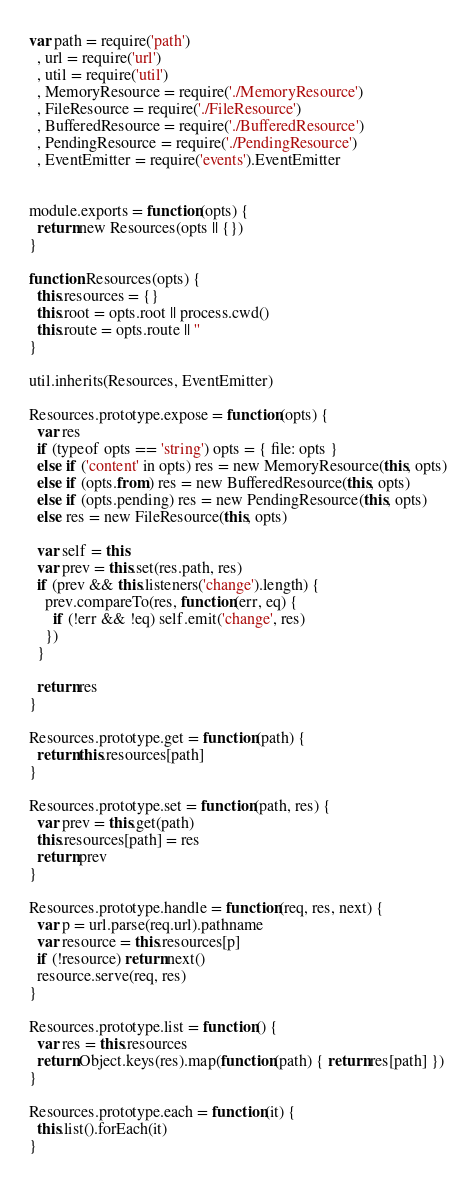<code> <loc_0><loc_0><loc_500><loc_500><_JavaScript_>var path = require('path')
  , url = require('url')
  , util = require('util')
  , MemoryResource = require('./MemoryResource')
  , FileResource = require('./FileResource')
  , BufferedResource = require('./BufferedResource')
  , PendingResource = require('./PendingResource')
  , EventEmitter = require('events').EventEmitter


module.exports = function(opts) {
  return new Resources(opts || {})
}

function Resources(opts) {
  this.resources = {}
  this.root = opts.root || process.cwd()
  this.route = opts.route || ''
}

util.inherits(Resources, EventEmitter)

Resources.prototype.expose = function(opts) {
  var res
  if (typeof opts == 'string') opts = { file: opts }
  else if ('content' in opts) res = new MemoryResource(this, opts)
  else if (opts.from) res = new BufferedResource(this, opts)
  else if (opts.pending) res = new PendingResource(this, opts)
  else res = new FileResource(this, opts)

  var self = this
  var prev = this.set(res.path, res)
  if (prev && this.listeners('change').length) {
    prev.compareTo(res, function(err, eq) {
      if (!err && !eq) self.emit('change', res)
    })
  }

  return res
}

Resources.prototype.get = function(path) {
  return this.resources[path]
}

Resources.prototype.set = function(path, res) {
  var prev = this.get(path)
  this.resources[path] = res
  return prev
}

Resources.prototype.handle = function(req, res, next) {
  var p = url.parse(req.url).pathname
  var resource = this.resources[p]
  if (!resource) return next()
  resource.serve(req, res)
}

Resources.prototype.list = function() {
  var res = this.resources
  return Object.keys(res).map(function(path) { return res[path] })
}

Resources.prototype.each = function(it) {
  this.list().forEach(it)
}
</code> 